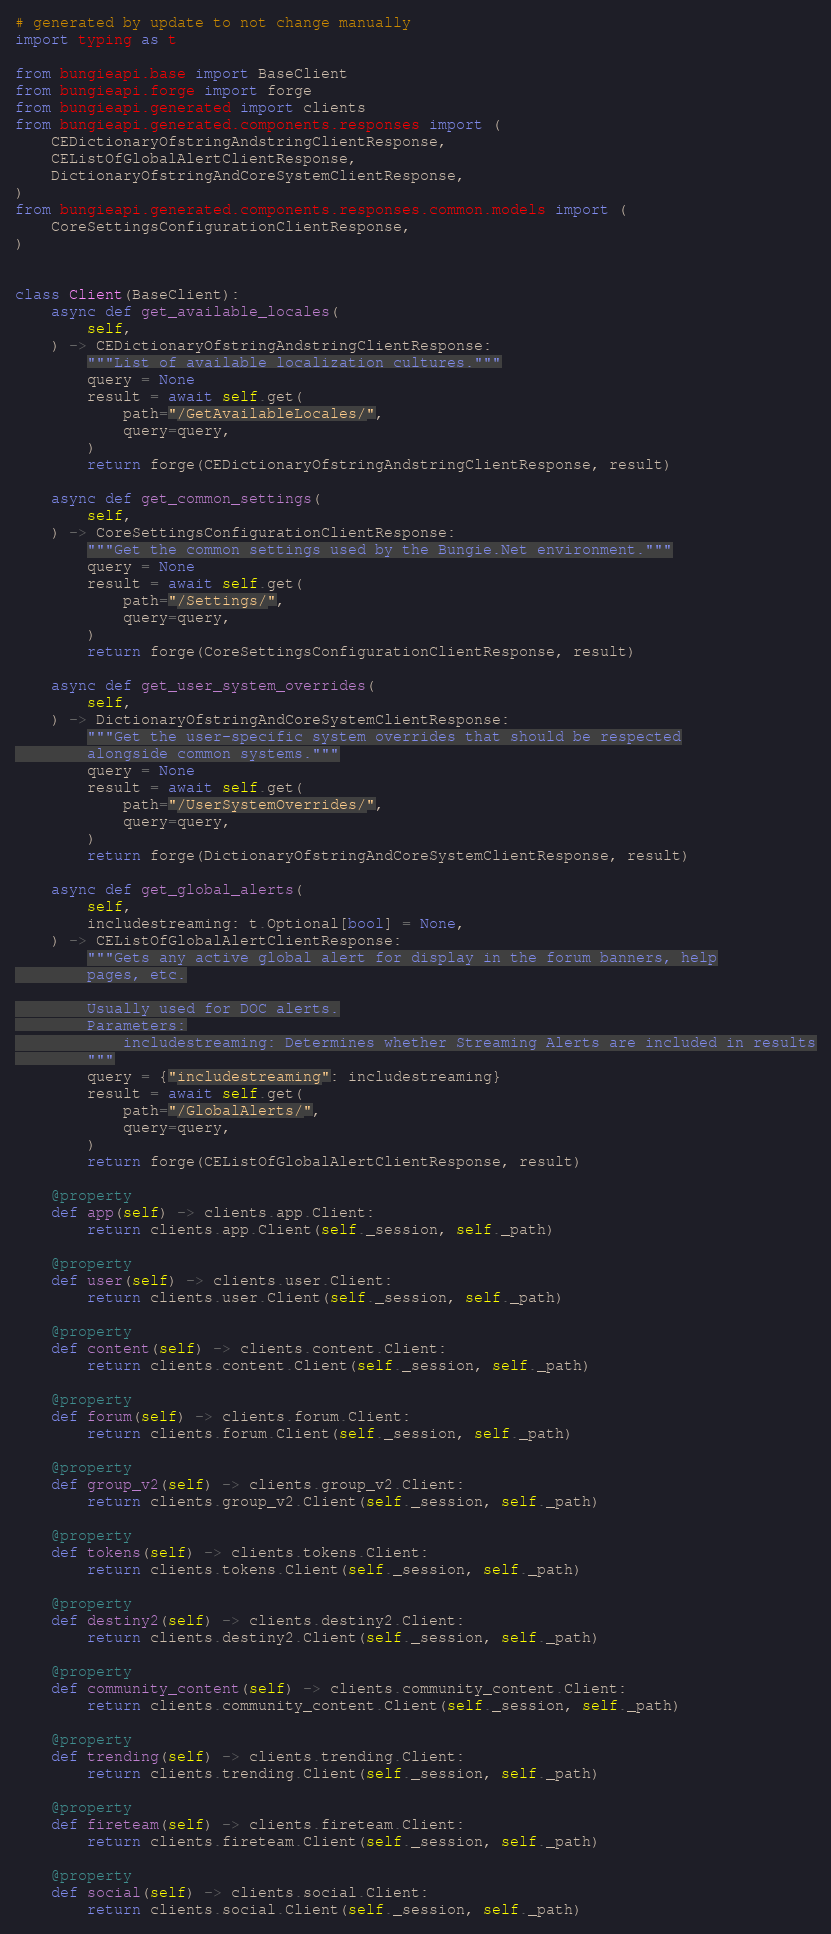<code> <loc_0><loc_0><loc_500><loc_500><_Python_># generated by update to not change manually
import typing as t

from bungieapi.base import BaseClient
from bungieapi.forge import forge
from bungieapi.generated import clients
from bungieapi.generated.components.responses import (
    CEDictionaryOfstringAndstringClientResponse,
    CEListOfGlobalAlertClientResponse,
    DictionaryOfstringAndCoreSystemClientResponse,
)
from bungieapi.generated.components.responses.common.models import (
    CoreSettingsConfigurationClientResponse,
)


class Client(BaseClient):
    async def get_available_locales(
        self,
    ) -> CEDictionaryOfstringAndstringClientResponse:
        """List of available localization cultures."""
        query = None
        result = await self.get(
            path="/GetAvailableLocales/",
            query=query,
        )
        return forge(CEDictionaryOfstringAndstringClientResponse, result)

    async def get_common_settings(
        self,
    ) -> CoreSettingsConfigurationClientResponse:
        """Get the common settings used by the Bungie.Net environment."""
        query = None
        result = await self.get(
            path="/Settings/",
            query=query,
        )
        return forge(CoreSettingsConfigurationClientResponse, result)

    async def get_user_system_overrides(
        self,
    ) -> DictionaryOfstringAndCoreSystemClientResponse:
        """Get the user-specific system overrides that should be respected
        alongside common systems."""
        query = None
        result = await self.get(
            path="/UserSystemOverrides/",
            query=query,
        )
        return forge(DictionaryOfstringAndCoreSystemClientResponse, result)

    async def get_global_alerts(
        self,
        includestreaming: t.Optional[bool] = None,
    ) -> CEListOfGlobalAlertClientResponse:
        """Gets any active global alert for display in the forum banners, help
        pages, etc.

        Usually used for DOC alerts.
        Parameters:
            includestreaming: Determines whether Streaming Alerts are included in results
        """
        query = {"includestreaming": includestreaming}
        result = await self.get(
            path="/GlobalAlerts/",
            query=query,
        )
        return forge(CEListOfGlobalAlertClientResponse, result)

    @property
    def app(self) -> clients.app.Client:
        return clients.app.Client(self._session, self._path)

    @property
    def user(self) -> clients.user.Client:
        return clients.user.Client(self._session, self._path)

    @property
    def content(self) -> clients.content.Client:
        return clients.content.Client(self._session, self._path)

    @property
    def forum(self) -> clients.forum.Client:
        return clients.forum.Client(self._session, self._path)

    @property
    def group_v2(self) -> clients.group_v2.Client:
        return clients.group_v2.Client(self._session, self._path)

    @property
    def tokens(self) -> clients.tokens.Client:
        return clients.tokens.Client(self._session, self._path)

    @property
    def destiny2(self) -> clients.destiny2.Client:
        return clients.destiny2.Client(self._session, self._path)

    @property
    def community_content(self) -> clients.community_content.Client:
        return clients.community_content.Client(self._session, self._path)

    @property
    def trending(self) -> clients.trending.Client:
        return clients.trending.Client(self._session, self._path)

    @property
    def fireteam(self) -> clients.fireteam.Client:
        return clients.fireteam.Client(self._session, self._path)

    @property
    def social(self) -> clients.social.Client:
        return clients.social.Client(self._session, self._path)
</code> 